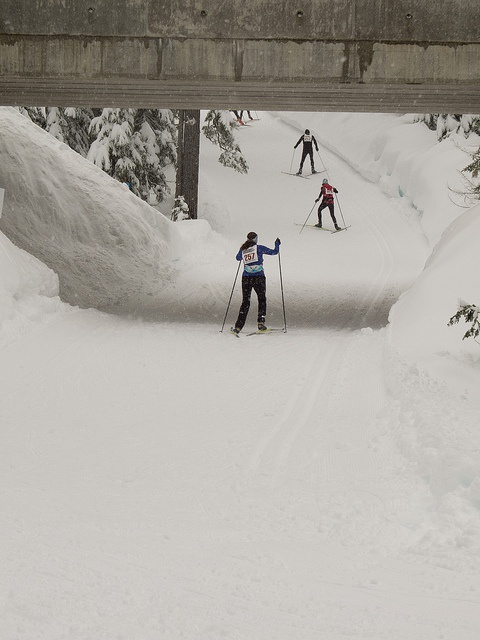Describe the objects in this image and their specific colors. I can see people in black, navy, gray, and darkgray tones, people in black, maroon, gray, and darkgray tones, people in black, darkgray, and gray tones, skis in black, darkgray, gray, and lightgray tones, and skis in black, darkgray, and gray tones in this image. 